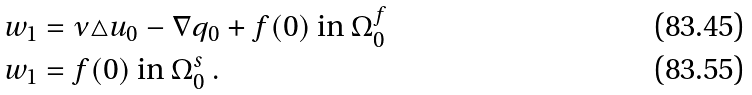<formula> <loc_0><loc_0><loc_500><loc_500>w _ { 1 } & = \nu \triangle u _ { 0 } - \nabla q _ { 0 } + f ( 0 ) \ \text {in} \ \Omega _ { 0 } ^ { f } \\ w _ { 1 } & = f ( 0 ) \ \text {in} \ \Omega _ { 0 } ^ { s } \ .</formula> 